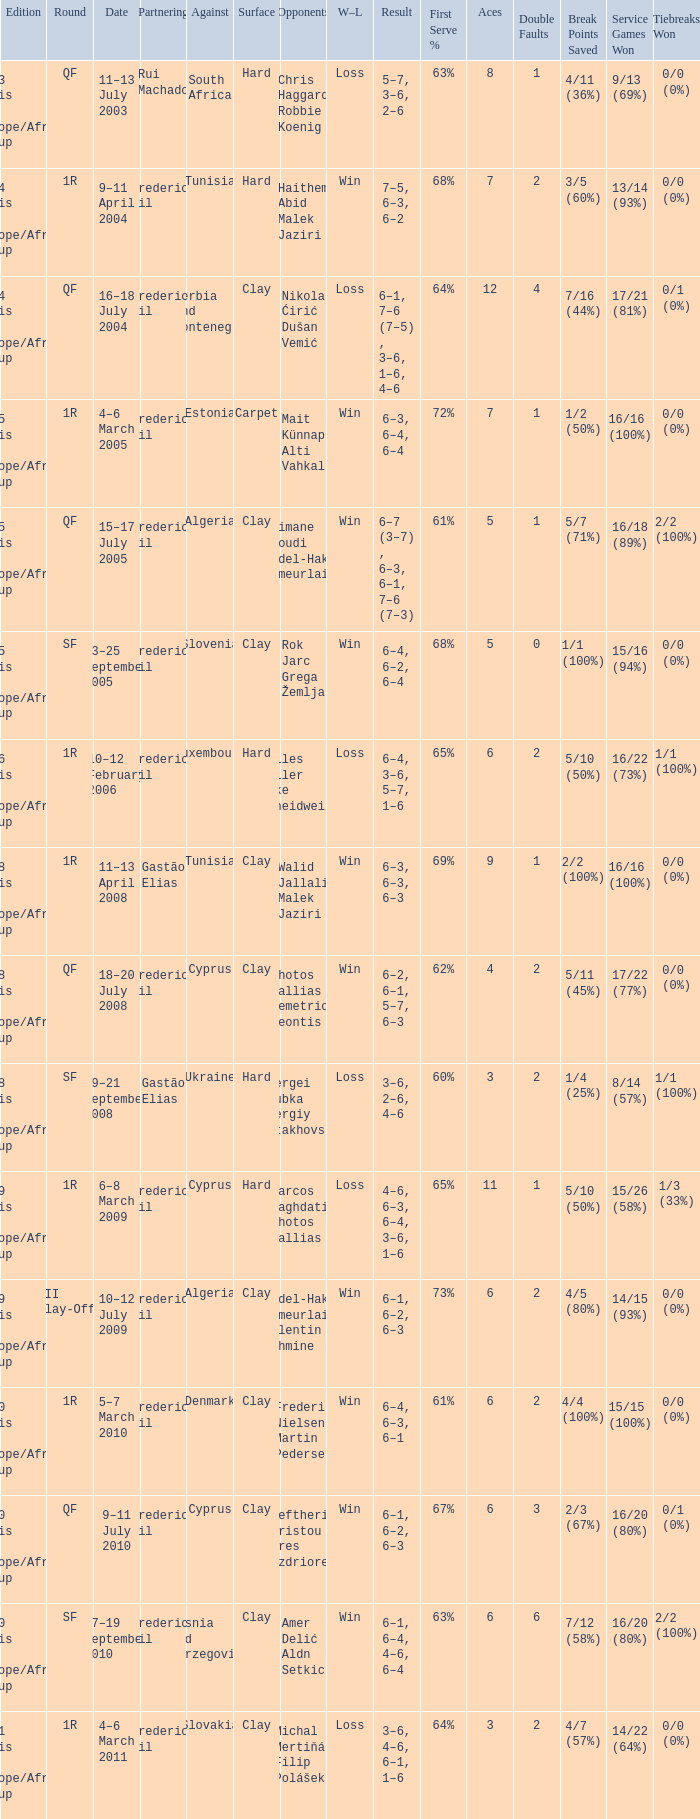How many rounds were there in the 2006 davis cup europe/africa group I? 1.0. 